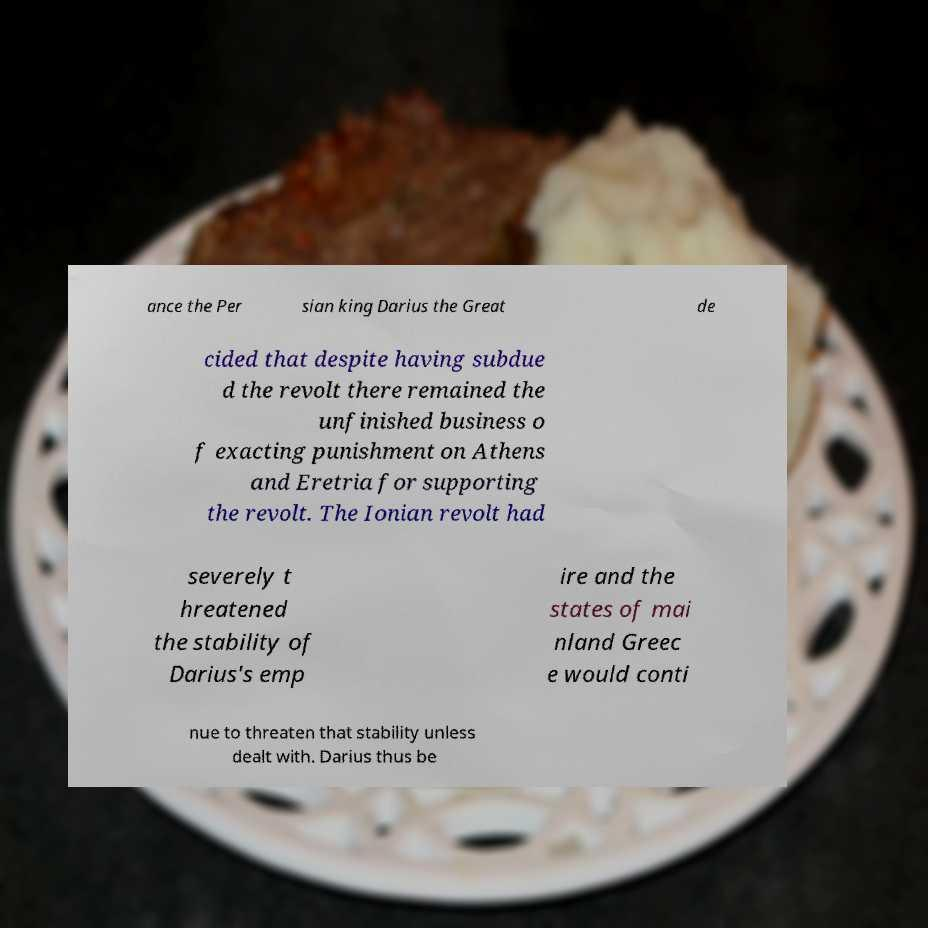Could you extract and type out the text from this image? ance the Per sian king Darius the Great de cided that despite having subdue d the revolt there remained the unfinished business o f exacting punishment on Athens and Eretria for supporting the revolt. The Ionian revolt had severely t hreatened the stability of Darius's emp ire and the states of mai nland Greec e would conti nue to threaten that stability unless dealt with. Darius thus be 